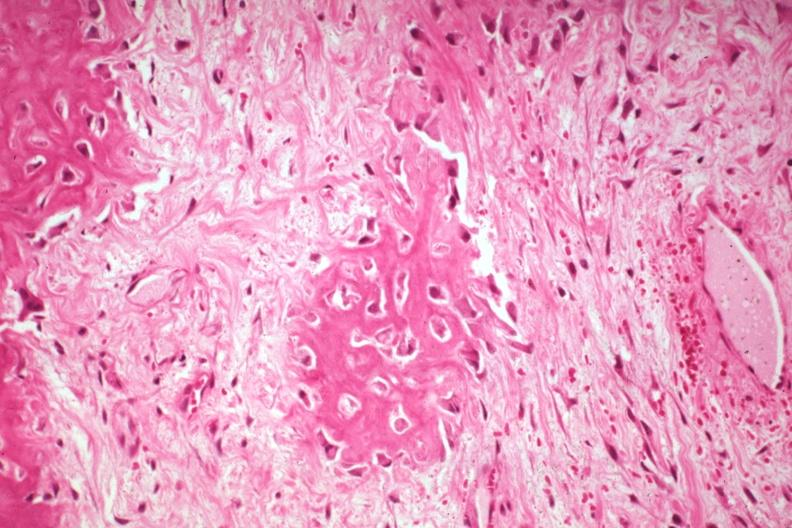what is present?
Answer the question using a single word or phrase. Joints 